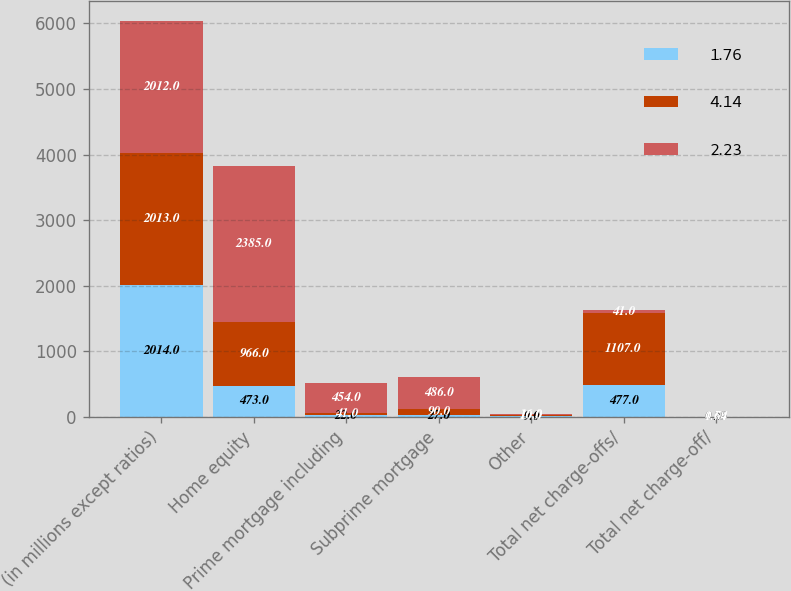Convert chart. <chart><loc_0><loc_0><loc_500><loc_500><stacked_bar_chart><ecel><fcel>(in millions except ratios)<fcel>Home equity<fcel>Prime mortgage including<fcel>Subprime mortgage<fcel>Other<fcel>Total net charge-offs/<fcel>Total net charge-off/<nl><fcel>1.76<fcel>2014<fcel>473<fcel>22<fcel>27<fcel>9<fcel>477<fcel>0.29<nl><fcel>4.14<fcel>2013<fcel>966<fcel>41<fcel>90<fcel>10<fcel>1107<fcel>0.64<nl><fcel>2.23<fcel>2012<fcel>2385<fcel>454<fcel>486<fcel>16<fcel>41<fcel>1.79<nl></chart> 